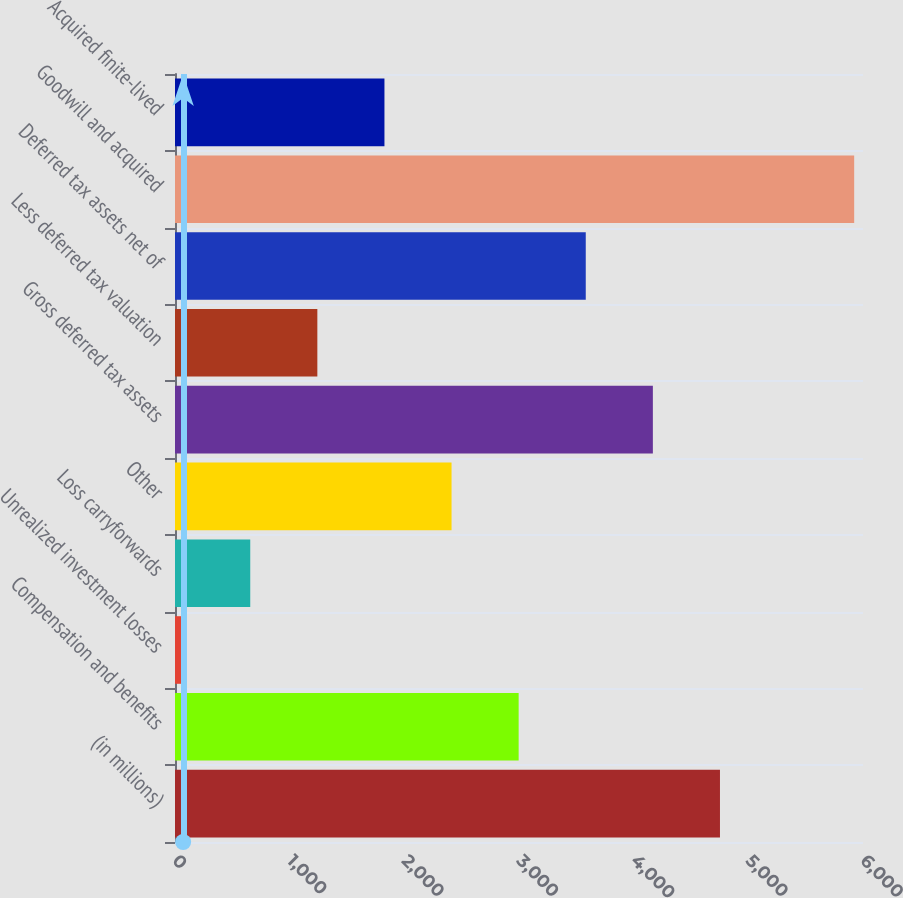Convert chart. <chart><loc_0><loc_0><loc_500><loc_500><bar_chart><fcel>(in millions)<fcel>Compensation and benefits<fcel>Unrealized investment losses<fcel>Loss carryforwards<fcel>Other<fcel>Gross deferred tax assets<fcel>Less deferred tax valuation<fcel>Deferred tax assets net of<fcel>Goodwill and acquired<fcel>Acquired finite-lived<nl><fcel>4752.6<fcel>2997<fcel>71<fcel>656.2<fcel>2411.8<fcel>4167.4<fcel>1241.4<fcel>3582.2<fcel>5923<fcel>1826.6<nl></chart> 